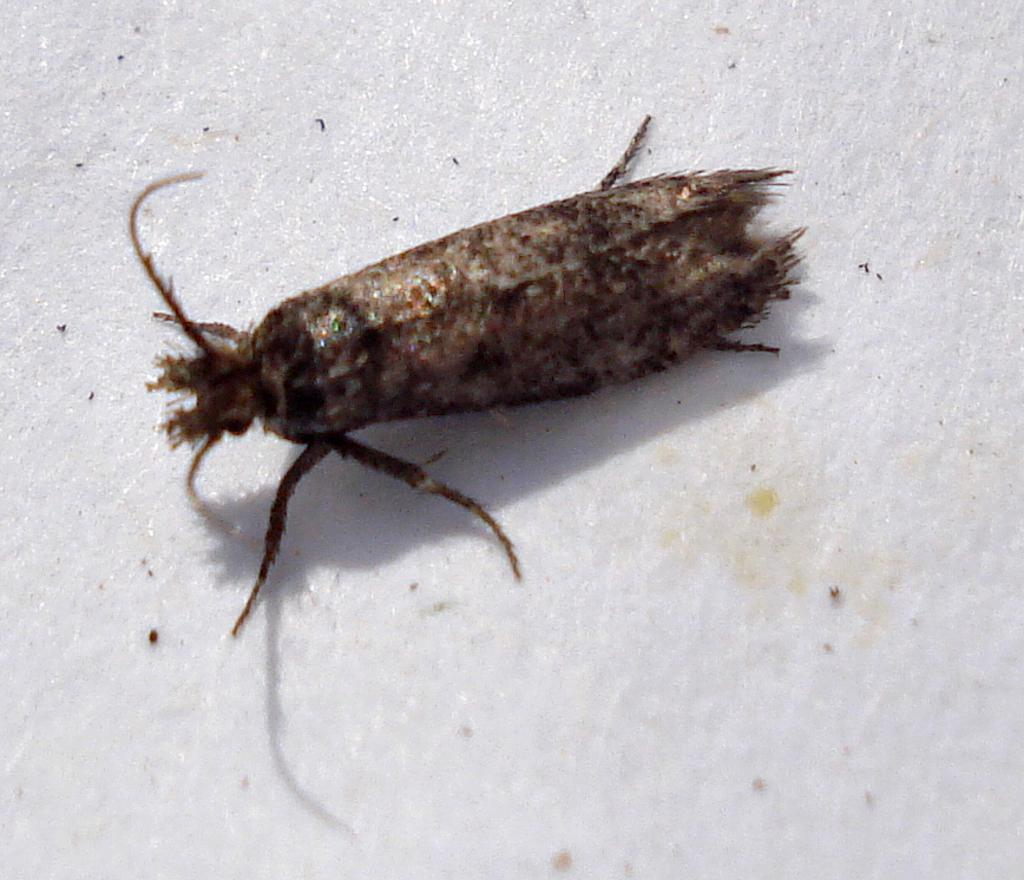What type of creature can be seen in the image? There is an insect in the image. What is the color of the surface on which the insect is located? The insect is on a white surface. How does the zebra transport the insect in the image? There is no zebra present in the image, so it cannot transport the insect. 